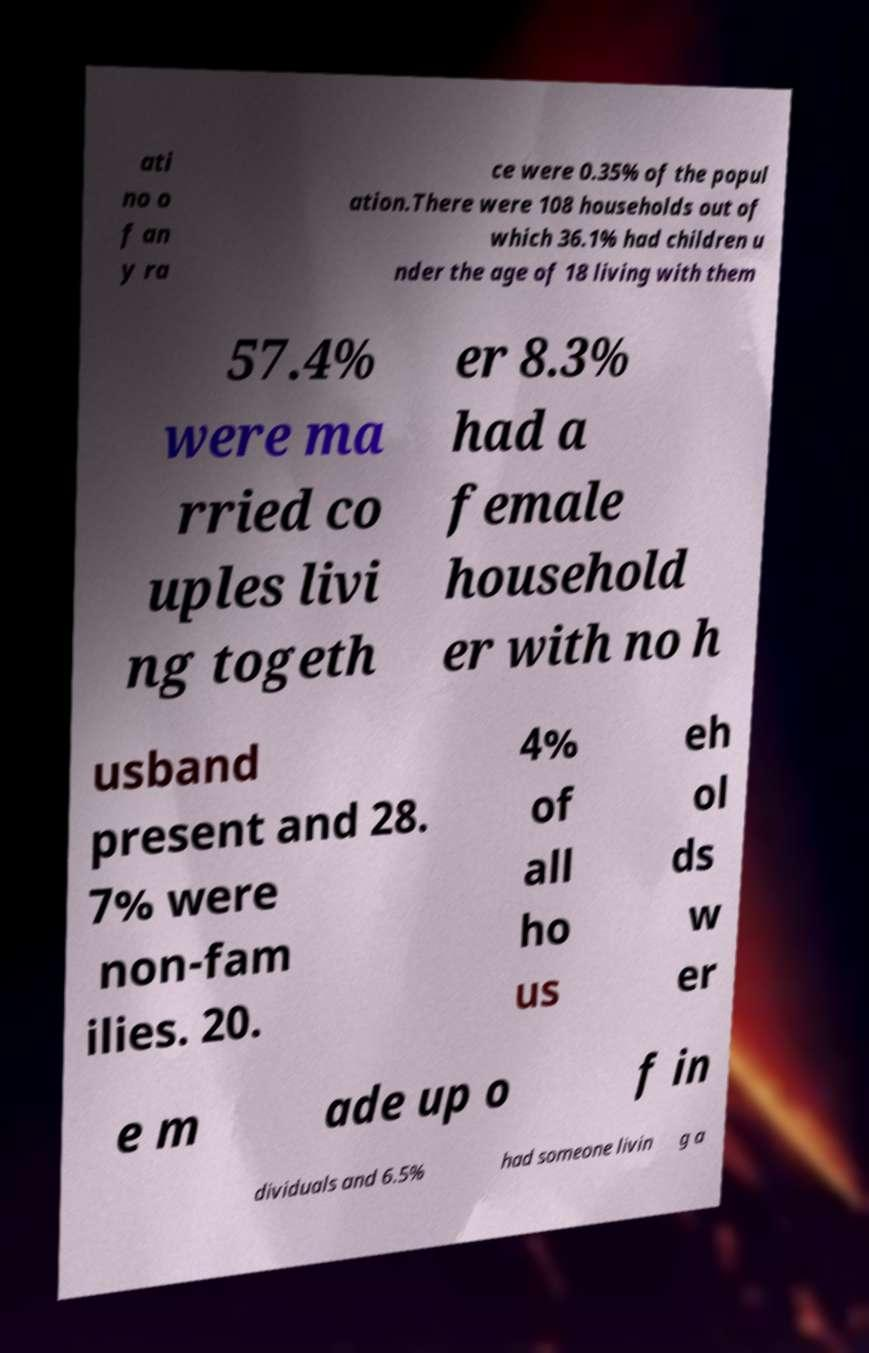For documentation purposes, I need the text within this image transcribed. Could you provide that? ati no o f an y ra ce were 0.35% of the popul ation.There were 108 households out of which 36.1% had children u nder the age of 18 living with them 57.4% were ma rried co uples livi ng togeth er 8.3% had a female household er with no h usband present and 28. 7% were non-fam ilies. 20. 4% of all ho us eh ol ds w er e m ade up o f in dividuals and 6.5% had someone livin g a 